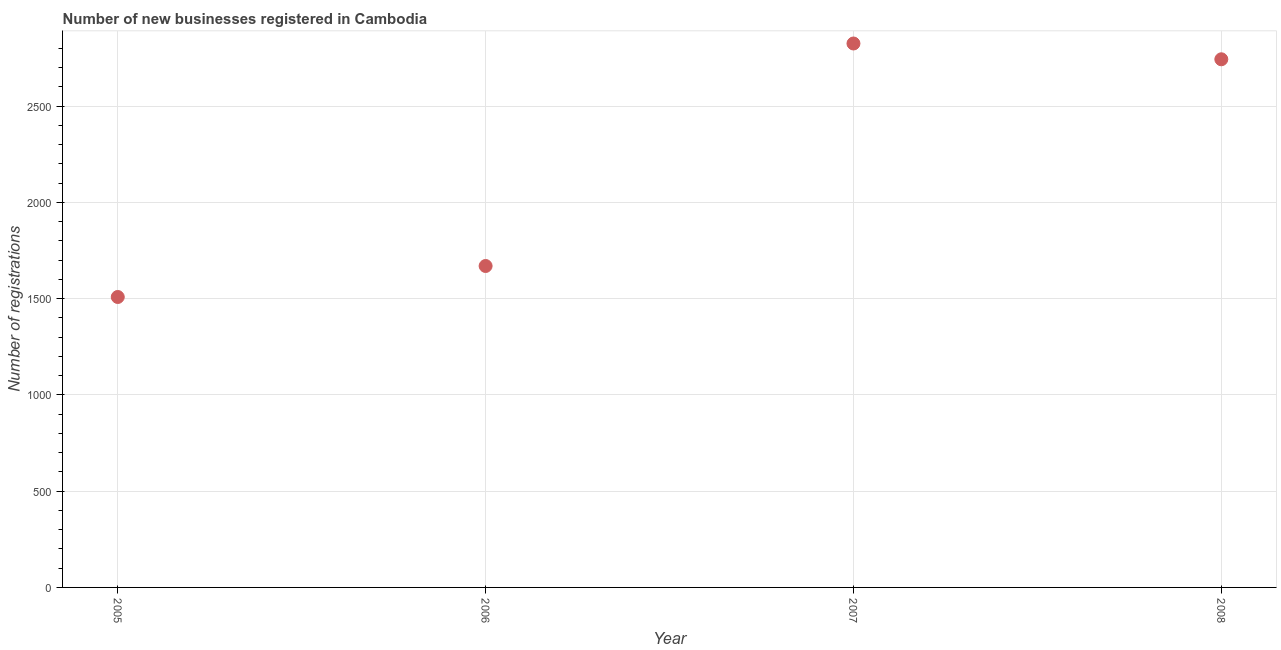What is the number of new business registrations in 2005?
Provide a short and direct response. 1509. Across all years, what is the maximum number of new business registrations?
Ensure brevity in your answer.  2826. Across all years, what is the minimum number of new business registrations?
Make the answer very short. 1509. In which year was the number of new business registrations maximum?
Make the answer very short. 2007. In which year was the number of new business registrations minimum?
Ensure brevity in your answer.  2005. What is the sum of the number of new business registrations?
Your answer should be very brief. 8749. What is the difference between the number of new business registrations in 2005 and 2007?
Your answer should be very brief. -1317. What is the average number of new business registrations per year?
Offer a very short reply. 2187.25. What is the median number of new business registrations?
Offer a very short reply. 2207. Do a majority of the years between 2006 and 2005 (inclusive) have number of new business registrations greater than 1000 ?
Your response must be concise. No. What is the ratio of the number of new business registrations in 2007 to that in 2008?
Your response must be concise. 1.03. Is the difference between the number of new business registrations in 2005 and 2006 greater than the difference between any two years?
Ensure brevity in your answer.  No. What is the difference between the highest and the second highest number of new business registrations?
Your answer should be compact. 82. Is the sum of the number of new business registrations in 2006 and 2008 greater than the maximum number of new business registrations across all years?
Offer a terse response. Yes. What is the difference between the highest and the lowest number of new business registrations?
Give a very brief answer. 1317. Does the number of new business registrations monotonically increase over the years?
Your response must be concise. No. How many dotlines are there?
Make the answer very short. 1. What is the difference between two consecutive major ticks on the Y-axis?
Make the answer very short. 500. Does the graph contain grids?
Make the answer very short. Yes. What is the title of the graph?
Offer a terse response. Number of new businesses registered in Cambodia. What is the label or title of the X-axis?
Ensure brevity in your answer.  Year. What is the label or title of the Y-axis?
Make the answer very short. Number of registrations. What is the Number of registrations in 2005?
Your response must be concise. 1509. What is the Number of registrations in 2006?
Make the answer very short. 1670. What is the Number of registrations in 2007?
Your answer should be very brief. 2826. What is the Number of registrations in 2008?
Keep it short and to the point. 2744. What is the difference between the Number of registrations in 2005 and 2006?
Ensure brevity in your answer.  -161. What is the difference between the Number of registrations in 2005 and 2007?
Offer a very short reply. -1317. What is the difference between the Number of registrations in 2005 and 2008?
Your answer should be compact. -1235. What is the difference between the Number of registrations in 2006 and 2007?
Ensure brevity in your answer.  -1156. What is the difference between the Number of registrations in 2006 and 2008?
Your answer should be compact. -1074. What is the difference between the Number of registrations in 2007 and 2008?
Provide a short and direct response. 82. What is the ratio of the Number of registrations in 2005 to that in 2006?
Offer a terse response. 0.9. What is the ratio of the Number of registrations in 2005 to that in 2007?
Make the answer very short. 0.53. What is the ratio of the Number of registrations in 2005 to that in 2008?
Keep it short and to the point. 0.55. What is the ratio of the Number of registrations in 2006 to that in 2007?
Give a very brief answer. 0.59. What is the ratio of the Number of registrations in 2006 to that in 2008?
Your answer should be compact. 0.61. What is the ratio of the Number of registrations in 2007 to that in 2008?
Your answer should be compact. 1.03. 